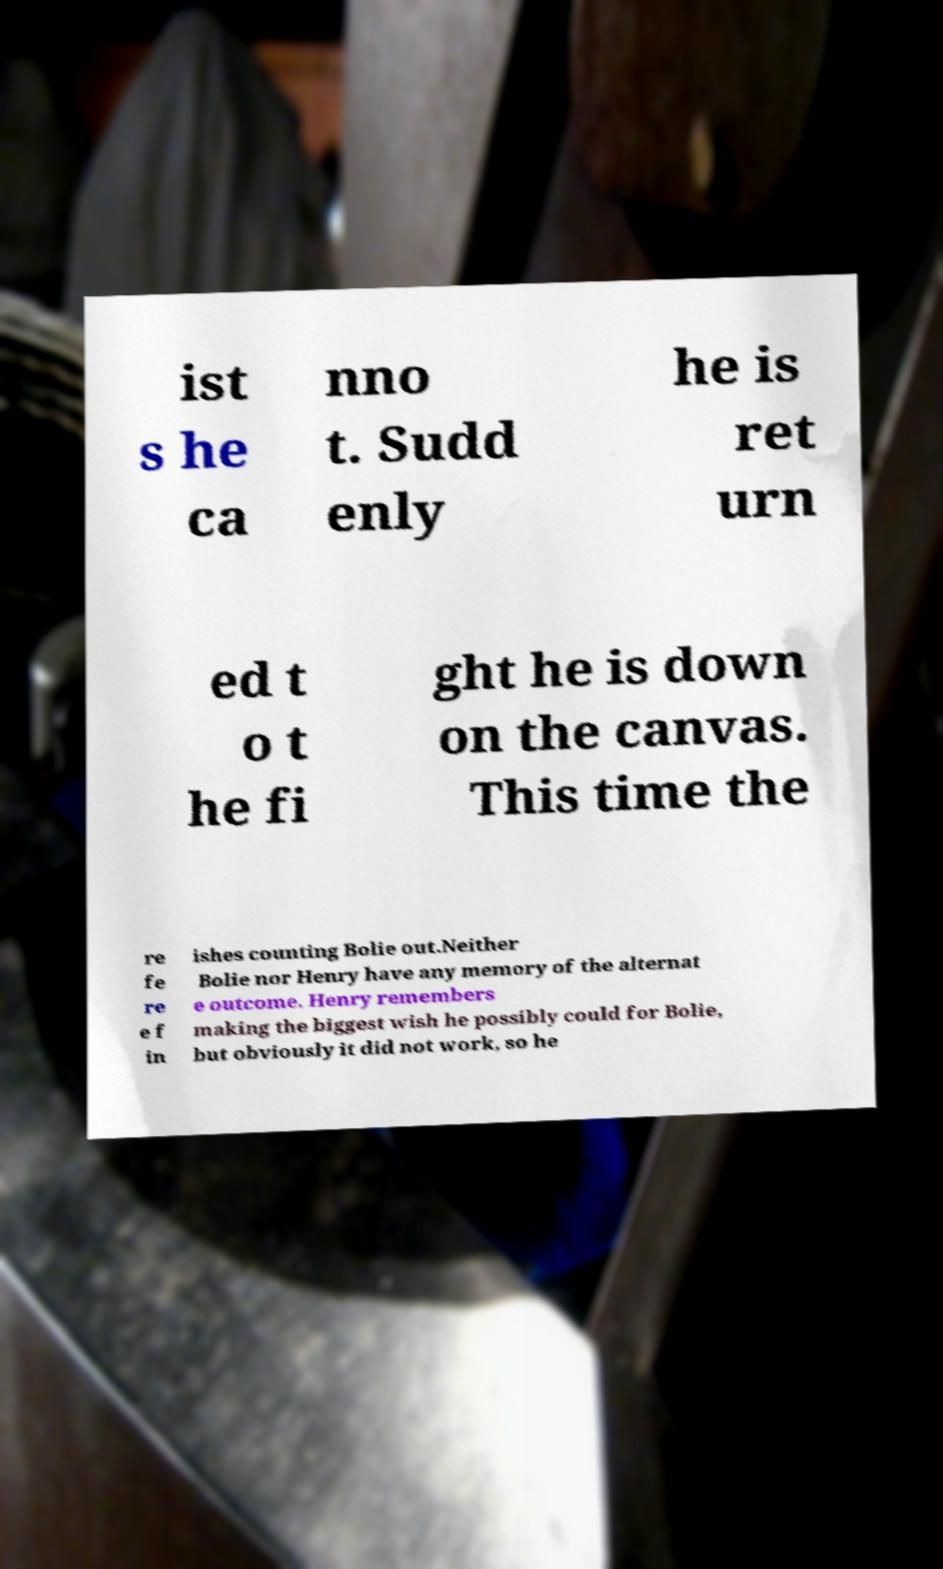I need the written content from this picture converted into text. Can you do that? ist s he ca nno t. Sudd enly he is ret urn ed t o t he fi ght he is down on the canvas. This time the re fe re e f in ishes counting Bolie out.Neither Bolie nor Henry have any memory of the alternat e outcome. Henry remembers making the biggest wish he possibly could for Bolie, but obviously it did not work, so he 